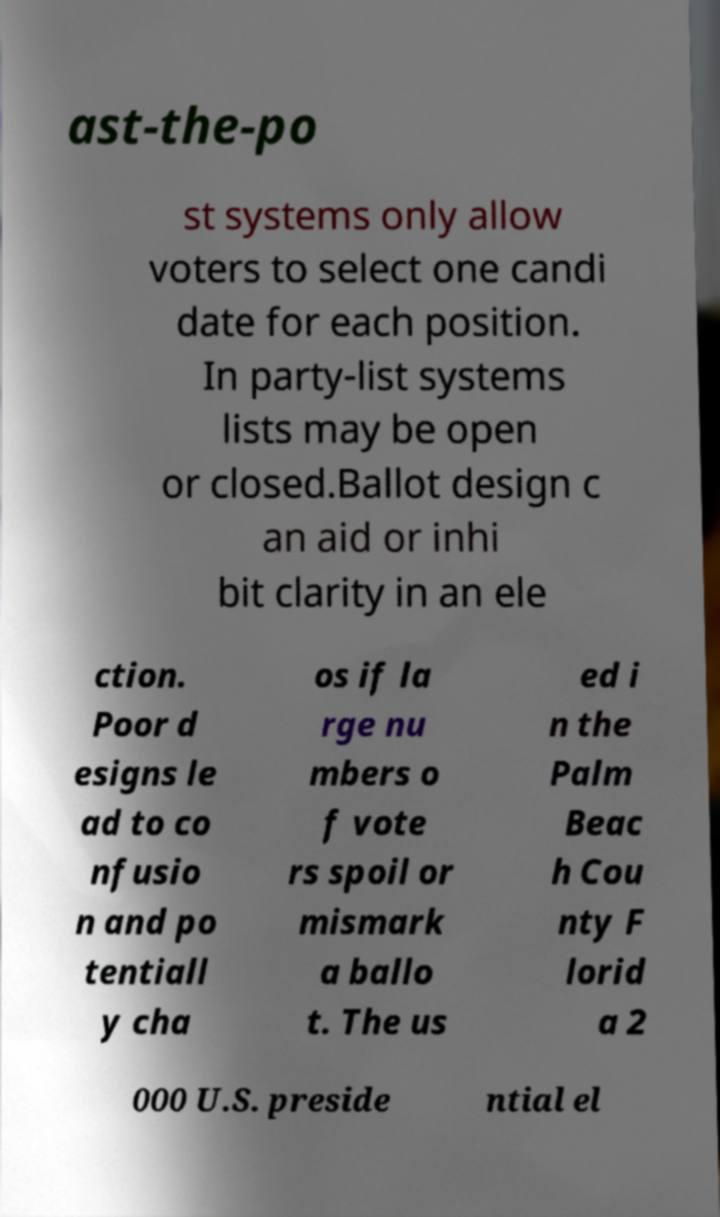There's text embedded in this image that I need extracted. Can you transcribe it verbatim? ast-the-po st systems only allow voters to select one candi date for each position. In party-list systems lists may be open or closed.Ballot design c an aid or inhi bit clarity in an ele ction. Poor d esigns le ad to co nfusio n and po tentiall y cha os if la rge nu mbers o f vote rs spoil or mismark a ballo t. The us ed i n the Palm Beac h Cou nty F lorid a 2 000 U.S. preside ntial el 